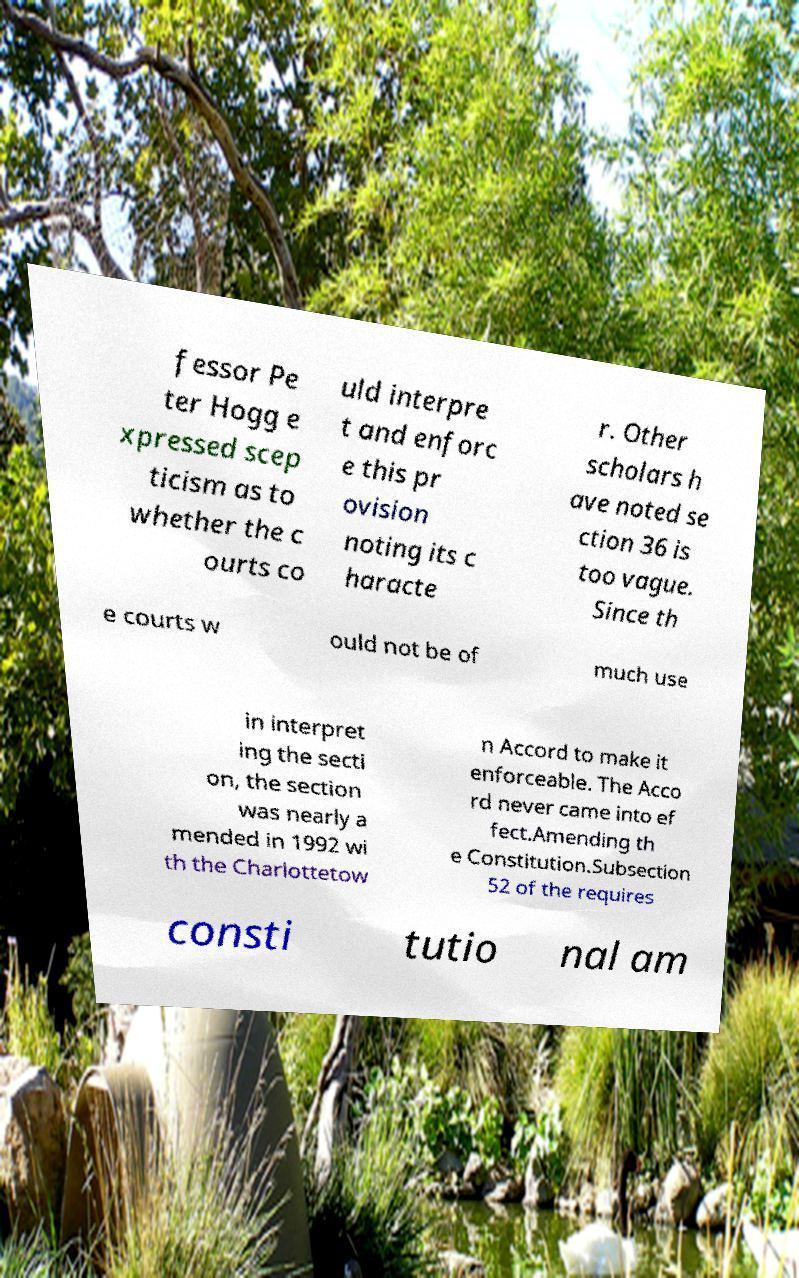I need the written content from this picture converted into text. Can you do that? fessor Pe ter Hogg e xpressed scep ticism as to whether the c ourts co uld interpre t and enforc e this pr ovision noting its c haracte r. Other scholars h ave noted se ction 36 is too vague. Since th e courts w ould not be of much use in interpret ing the secti on, the section was nearly a mended in 1992 wi th the Charlottetow n Accord to make it enforceable. The Acco rd never came into ef fect.Amending th e Constitution.Subsection 52 of the requires consti tutio nal am 